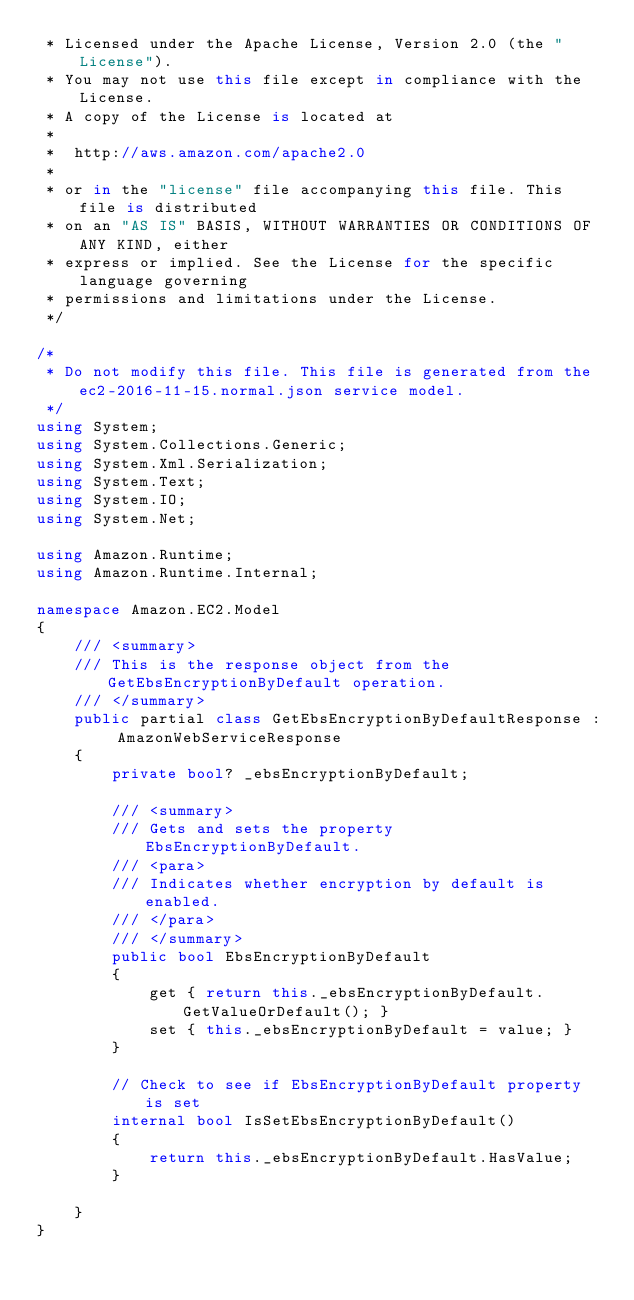Convert code to text. <code><loc_0><loc_0><loc_500><loc_500><_C#_> * Licensed under the Apache License, Version 2.0 (the "License").
 * You may not use this file except in compliance with the License.
 * A copy of the License is located at
 * 
 *  http://aws.amazon.com/apache2.0
 * 
 * or in the "license" file accompanying this file. This file is distributed
 * on an "AS IS" BASIS, WITHOUT WARRANTIES OR CONDITIONS OF ANY KIND, either
 * express or implied. See the License for the specific language governing
 * permissions and limitations under the License.
 */

/*
 * Do not modify this file. This file is generated from the ec2-2016-11-15.normal.json service model.
 */
using System;
using System.Collections.Generic;
using System.Xml.Serialization;
using System.Text;
using System.IO;
using System.Net;

using Amazon.Runtime;
using Amazon.Runtime.Internal;

namespace Amazon.EC2.Model
{
    /// <summary>
    /// This is the response object from the GetEbsEncryptionByDefault operation.
    /// </summary>
    public partial class GetEbsEncryptionByDefaultResponse : AmazonWebServiceResponse
    {
        private bool? _ebsEncryptionByDefault;

        /// <summary>
        /// Gets and sets the property EbsEncryptionByDefault. 
        /// <para>
        /// Indicates whether encryption by default is enabled.
        /// </para>
        /// </summary>
        public bool EbsEncryptionByDefault
        {
            get { return this._ebsEncryptionByDefault.GetValueOrDefault(); }
            set { this._ebsEncryptionByDefault = value; }
        }

        // Check to see if EbsEncryptionByDefault property is set
        internal bool IsSetEbsEncryptionByDefault()
        {
            return this._ebsEncryptionByDefault.HasValue; 
        }

    }
}</code> 